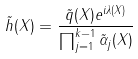Convert formula to latex. <formula><loc_0><loc_0><loc_500><loc_500>\tilde { h } ( X ) = \frac { \tilde { q } ( X ) e ^ { i \lambda ( X ) } } { \prod _ { j = 1 } ^ { k - 1 } \tilde { \alpha } _ { j } ( X ) }</formula> 